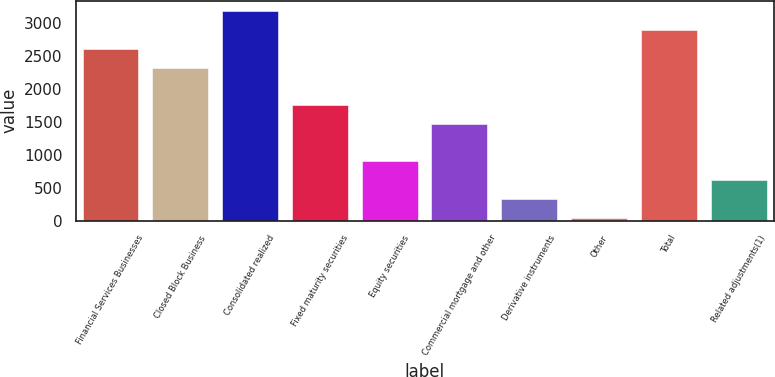Convert chart. <chart><loc_0><loc_0><loc_500><loc_500><bar_chart><fcel>Financial Services Businesses<fcel>Closed Block Business<fcel>Consolidated realized<fcel>Fixed maturity securities<fcel>Equity securities<fcel>Commercial mortgage and other<fcel>Derivative instruments<fcel>Other<fcel>Total<fcel>Related adjustments(1)<nl><fcel>2611.4<fcel>2325.8<fcel>3182.6<fcel>1754.6<fcel>897.8<fcel>1469<fcel>326.6<fcel>41<fcel>2897<fcel>612.2<nl></chart> 